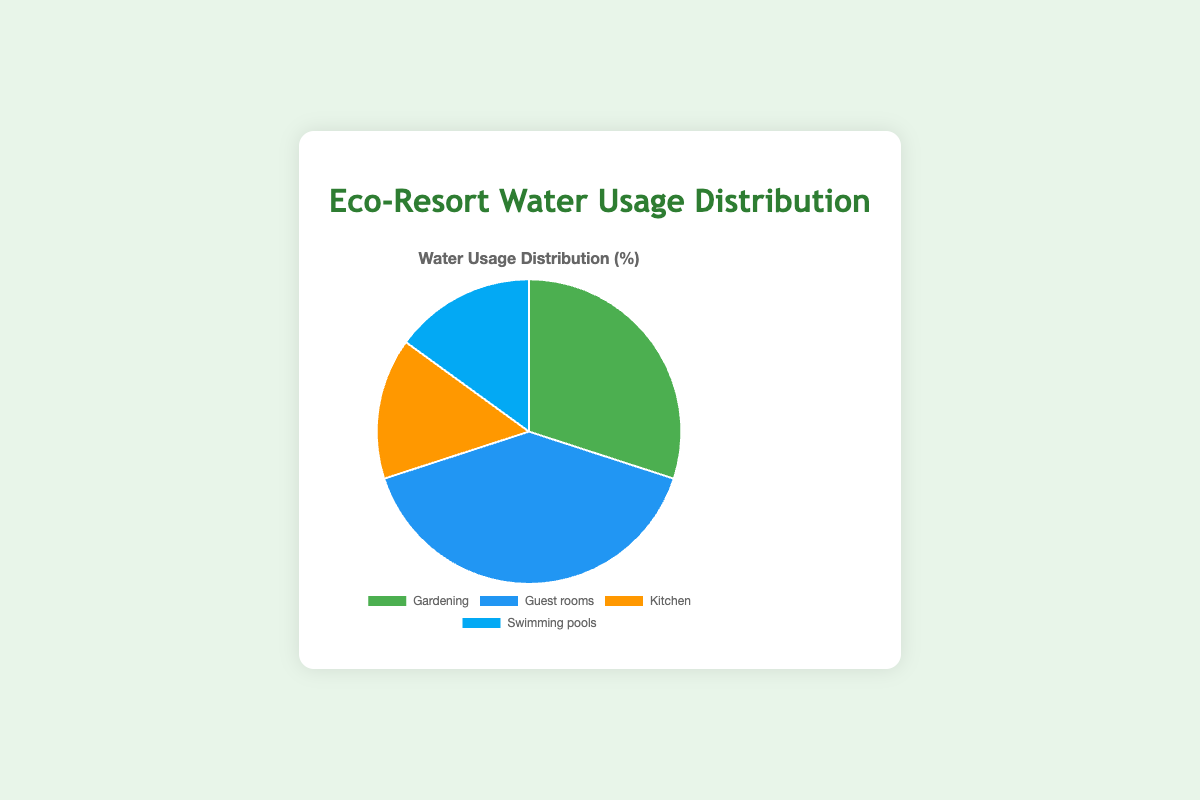How much water usage percentage is accounted for by activities related to the resort's operation? To find the total water usage percentage related to the resort's operation, sum the percentages of Guest rooms, Kitchen, and Swimming pools: 40% + 15% + 15% = 70%
Answer: 70% Which activity uses the most water? The activity with the highest percentage in the pie chart uses the most water. According to the data, Guest rooms use 40%, which is the highest.
Answer: Guest rooms What is the water usage difference between Gardening and Kitchen activities? To find the water usage difference between Gardening and Kitchen, subtract the Kitchen percentage from the Gardening percentage: 30% - 15% = 15%
Answer: 15% Are the water usage percentages for Swimming pools and Kitchen equal? Compare the percentages for Swimming pools and Kitchen. Both have a usage of 15%.
Answer: Yes What combined percentage of water usage do Gardening and Guest rooms represent? To find the combined percentage, add the percentages for Gardening and Guest rooms: 30% + 40% = 70%
Answer: 70% Which activity uses double the water of the Kitchen? To see which activity uses double the water of the Kitchen (15%), look for an activity with 30%. Gardening uses 30%.
Answer: Gardening What is the smallest category in the pie chart? The smallest category is the one with the lowest percentage. Kitchen and Swimming pools each have 15%, the smallest in this chart.
Answer: Kitchen, Swimming pools Is the combined water usage for Kitchen and Swimming pools less than that for Guest rooms? Calculate the combined water usage for Kitchen and Swimming pools: 15% + 15% = 30% and compare it to Guest rooms: 40%. 30% is less than 40%.
Answer: Yes What fraction of water usage is accounted for by the Kitchen and Swimming pools combined? The combined water usage for Kitchen and Swimming pools is 30%. To express it as a fraction of the total 100%, it is 30/100 or 3/10.
Answer: 3/10 